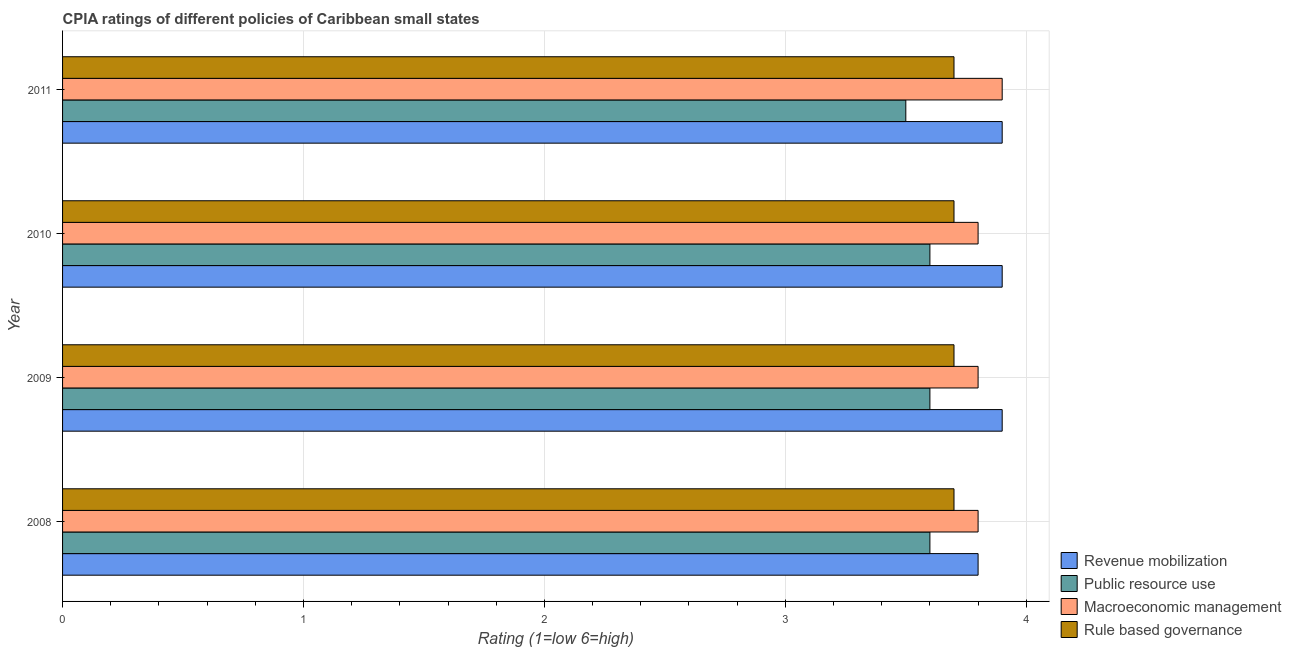How many different coloured bars are there?
Offer a terse response. 4. How many groups of bars are there?
Your answer should be compact. 4. Are the number of bars on each tick of the Y-axis equal?
Your response must be concise. Yes. How many bars are there on the 2nd tick from the bottom?
Provide a short and direct response. 4. In how many cases, is the number of bars for a given year not equal to the number of legend labels?
Give a very brief answer. 0. What is the cpia rating of macroeconomic management in 2009?
Provide a short and direct response. 3.8. In which year was the cpia rating of revenue mobilization maximum?
Provide a short and direct response. 2009. In which year was the cpia rating of public resource use minimum?
Provide a short and direct response. 2011. What is the difference between the cpia rating of macroeconomic management in 2008 and that in 2009?
Your answer should be very brief. 0. What is the difference between the cpia rating of revenue mobilization in 2008 and the cpia rating of macroeconomic management in 2011?
Your answer should be very brief. -0.1. What is the average cpia rating of revenue mobilization per year?
Make the answer very short. 3.88. In the year 2009, what is the difference between the cpia rating of rule based governance and cpia rating of public resource use?
Provide a short and direct response. 0.1. In how many years, is the cpia rating of public resource use greater than 3.2 ?
Ensure brevity in your answer.  4. Is the cpia rating of public resource use in 2010 less than that in 2011?
Give a very brief answer. No. Is the difference between the cpia rating of macroeconomic management in 2008 and 2010 greater than the difference between the cpia rating of revenue mobilization in 2008 and 2010?
Provide a succinct answer. Yes. What is the difference between the highest and the second highest cpia rating of rule based governance?
Provide a short and direct response. 0. What is the difference between the highest and the lowest cpia rating of public resource use?
Your answer should be compact. 0.1. In how many years, is the cpia rating of public resource use greater than the average cpia rating of public resource use taken over all years?
Give a very brief answer. 3. Is the sum of the cpia rating of rule based governance in 2010 and 2011 greater than the maximum cpia rating of revenue mobilization across all years?
Offer a terse response. Yes. What does the 1st bar from the top in 2011 represents?
Provide a succinct answer. Rule based governance. What does the 2nd bar from the bottom in 2010 represents?
Make the answer very short. Public resource use. What is the difference between two consecutive major ticks on the X-axis?
Keep it short and to the point. 1. Does the graph contain any zero values?
Offer a terse response. No. Does the graph contain grids?
Your answer should be very brief. Yes. Where does the legend appear in the graph?
Ensure brevity in your answer.  Bottom right. How are the legend labels stacked?
Provide a succinct answer. Vertical. What is the title of the graph?
Ensure brevity in your answer.  CPIA ratings of different policies of Caribbean small states. What is the label or title of the X-axis?
Offer a terse response. Rating (1=low 6=high). What is the label or title of the Y-axis?
Provide a succinct answer. Year. What is the Rating (1=low 6=high) in Public resource use in 2008?
Make the answer very short. 3.6. What is the Rating (1=low 6=high) in Rule based governance in 2008?
Your answer should be compact. 3.7. What is the Rating (1=low 6=high) in Public resource use in 2009?
Your response must be concise. 3.6. What is the Rating (1=low 6=high) of Rule based governance in 2009?
Ensure brevity in your answer.  3.7. What is the Rating (1=low 6=high) in Revenue mobilization in 2010?
Ensure brevity in your answer.  3.9. What is the Rating (1=low 6=high) of Public resource use in 2010?
Offer a very short reply. 3.6. What is the Rating (1=low 6=high) in Revenue mobilization in 2011?
Ensure brevity in your answer.  3.9. What is the Rating (1=low 6=high) in Macroeconomic management in 2011?
Your response must be concise. 3.9. What is the Rating (1=low 6=high) in Rule based governance in 2011?
Give a very brief answer. 3.7. Across all years, what is the maximum Rating (1=low 6=high) in Public resource use?
Provide a short and direct response. 3.6. Across all years, what is the maximum Rating (1=low 6=high) of Rule based governance?
Keep it short and to the point. 3.7. Across all years, what is the minimum Rating (1=low 6=high) of Revenue mobilization?
Offer a terse response. 3.8. What is the total Rating (1=low 6=high) in Public resource use in the graph?
Provide a succinct answer. 14.3. What is the total Rating (1=low 6=high) in Macroeconomic management in the graph?
Your response must be concise. 15.3. What is the difference between the Rating (1=low 6=high) of Public resource use in 2008 and that in 2009?
Your response must be concise. 0. What is the difference between the Rating (1=low 6=high) of Macroeconomic management in 2008 and that in 2009?
Keep it short and to the point. 0. What is the difference between the Rating (1=low 6=high) of Rule based governance in 2008 and that in 2009?
Provide a short and direct response. 0. What is the difference between the Rating (1=low 6=high) in Public resource use in 2008 and that in 2010?
Give a very brief answer. 0. What is the difference between the Rating (1=low 6=high) in Rule based governance in 2008 and that in 2010?
Provide a short and direct response. 0. What is the difference between the Rating (1=low 6=high) of Rule based governance in 2008 and that in 2011?
Make the answer very short. 0. What is the difference between the Rating (1=low 6=high) of Public resource use in 2009 and that in 2010?
Provide a short and direct response. 0. What is the difference between the Rating (1=low 6=high) of Macroeconomic management in 2009 and that in 2010?
Keep it short and to the point. 0. What is the difference between the Rating (1=low 6=high) in Revenue mobilization in 2009 and that in 2011?
Ensure brevity in your answer.  0. What is the difference between the Rating (1=low 6=high) in Rule based governance in 2009 and that in 2011?
Your response must be concise. 0. What is the difference between the Rating (1=low 6=high) of Macroeconomic management in 2010 and that in 2011?
Your answer should be compact. -0.1. What is the difference between the Rating (1=low 6=high) in Rule based governance in 2010 and that in 2011?
Keep it short and to the point. 0. What is the difference between the Rating (1=low 6=high) of Revenue mobilization in 2008 and the Rating (1=low 6=high) of Macroeconomic management in 2009?
Offer a very short reply. 0. What is the difference between the Rating (1=low 6=high) in Public resource use in 2008 and the Rating (1=low 6=high) in Rule based governance in 2009?
Your answer should be compact. -0.1. What is the difference between the Rating (1=low 6=high) of Macroeconomic management in 2008 and the Rating (1=low 6=high) of Rule based governance in 2009?
Ensure brevity in your answer.  0.1. What is the difference between the Rating (1=low 6=high) in Revenue mobilization in 2008 and the Rating (1=low 6=high) in Rule based governance in 2010?
Your answer should be compact. 0.1. What is the difference between the Rating (1=low 6=high) in Public resource use in 2008 and the Rating (1=low 6=high) in Macroeconomic management in 2010?
Provide a short and direct response. -0.2. What is the difference between the Rating (1=low 6=high) of Public resource use in 2008 and the Rating (1=low 6=high) of Rule based governance in 2010?
Your response must be concise. -0.1. What is the difference between the Rating (1=low 6=high) of Revenue mobilization in 2008 and the Rating (1=low 6=high) of Public resource use in 2011?
Provide a succinct answer. 0.3. What is the difference between the Rating (1=low 6=high) in Revenue mobilization in 2008 and the Rating (1=low 6=high) in Macroeconomic management in 2011?
Offer a terse response. -0.1. What is the difference between the Rating (1=low 6=high) of Public resource use in 2008 and the Rating (1=low 6=high) of Rule based governance in 2011?
Your response must be concise. -0.1. What is the difference between the Rating (1=low 6=high) of Macroeconomic management in 2008 and the Rating (1=low 6=high) of Rule based governance in 2011?
Offer a terse response. 0.1. What is the difference between the Rating (1=low 6=high) in Revenue mobilization in 2009 and the Rating (1=low 6=high) in Public resource use in 2010?
Give a very brief answer. 0.3. What is the difference between the Rating (1=low 6=high) in Public resource use in 2009 and the Rating (1=low 6=high) in Macroeconomic management in 2010?
Your answer should be very brief. -0.2. What is the difference between the Rating (1=low 6=high) in Macroeconomic management in 2009 and the Rating (1=low 6=high) in Rule based governance in 2010?
Make the answer very short. 0.1. What is the difference between the Rating (1=low 6=high) of Revenue mobilization in 2009 and the Rating (1=low 6=high) of Public resource use in 2011?
Give a very brief answer. 0.4. What is the difference between the Rating (1=low 6=high) of Revenue mobilization in 2009 and the Rating (1=low 6=high) of Macroeconomic management in 2011?
Ensure brevity in your answer.  0. What is the difference between the Rating (1=low 6=high) of Revenue mobilization in 2009 and the Rating (1=low 6=high) of Rule based governance in 2011?
Provide a succinct answer. 0.2. What is the difference between the Rating (1=low 6=high) of Public resource use in 2009 and the Rating (1=low 6=high) of Rule based governance in 2011?
Give a very brief answer. -0.1. What is the difference between the Rating (1=low 6=high) in Macroeconomic management in 2009 and the Rating (1=low 6=high) in Rule based governance in 2011?
Your answer should be very brief. 0.1. What is the difference between the Rating (1=low 6=high) in Revenue mobilization in 2010 and the Rating (1=low 6=high) in Macroeconomic management in 2011?
Provide a short and direct response. 0. What is the difference between the Rating (1=low 6=high) in Public resource use in 2010 and the Rating (1=low 6=high) in Macroeconomic management in 2011?
Give a very brief answer. -0.3. What is the difference between the Rating (1=low 6=high) in Public resource use in 2010 and the Rating (1=low 6=high) in Rule based governance in 2011?
Provide a short and direct response. -0.1. What is the difference between the Rating (1=low 6=high) in Macroeconomic management in 2010 and the Rating (1=low 6=high) in Rule based governance in 2011?
Your answer should be compact. 0.1. What is the average Rating (1=low 6=high) of Revenue mobilization per year?
Keep it short and to the point. 3.88. What is the average Rating (1=low 6=high) in Public resource use per year?
Make the answer very short. 3.58. What is the average Rating (1=low 6=high) in Macroeconomic management per year?
Your answer should be very brief. 3.83. In the year 2008, what is the difference between the Rating (1=low 6=high) in Revenue mobilization and Rating (1=low 6=high) in Public resource use?
Ensure brevity in your answer.  0.2. In the year 2008, what is the difference between the Rating (1=low 6=high) of Revenue mobilization and Rating (1=low 6=high) of Macroeconomic management?
Offer a terse response. 0. In the year 2008, what is the difference between the Rating (1=low 6=high) of Public resource use and Rating (1=low 6=high) of Rule based governance?
Give a very brief answer. -0.1. In the year 2008, what is the difference between the Rating (1=low 6=high) in Macroeconomic management and Rating (1=low 6=high) in Rule based governance?
Provide a succinct answer. 0.1. In the year 2009, what is the difference between the Rating (1=low 6=high) in Revenue mobilization and Rating (1=low 6=high) in Public resource use?
Your answer should be compact. 0.3. In the year 2009, what is the difference between the Rating (1=low 6=high) of Revenue mobilization and Rating (1=low 6=high) of Rule based governance?
Offer a very short reply. 0.2. In the year 2009, what is the difference between the Rating (1=low 6=high) of Public resource use and Rating (1=low 6=high) of Macroeconomic management?
Your response must be concise. -0.2. In the year 2009, what is the difference between the Rating (1=low 6=high) in Public resource use and Rating (1=low 6=high) in Rule based governance?
Your answer should be compact. -0.1. In the year 2009, what is the difference between the Rating (1=low 6=high) in Macroeconomic management and Rating (1=low 6=high) in Rule based governance?
Make the answer very short. 0.1. In the year 2010, what is the difference between the Rating (1=low 6=high) in Revenue mobilization and Rating (1=low 6=high) in Public resource use?
Your response must be concise. 0.3. In the year 2010, what is the difference between the Rating (1=low 6=high) of Revenue mobilization and Rating (1=low 6=high) of Macroeconomic management?
Provide a succinct answer. 0.1. In the year 2010, what is the difference between the Rating (1=low 6=high) in Macroeconomic management and Rating (1=low 6=high) in Rule based governance?
Keep it short and to the point. 0.1. In the year 2011, what is the difference between the Rating (1=low 6=high) in Revenue mobilization and Rating (1=low 6=high) in Public resource use?
Your answer should be very brief. 0.4. In the year 2011, what is the difference between the Rating (1=low 6=high) in Revenue mobilization and Rating (1=low 6=high) in Rule based governance?
Ensure brevity in your answer.  0.2. In the year 2011, what is the difference between the Rating (1=low 6=high) of Public resource use and Rating (1=low 6=high) of Macroeconomic management?
Your answer should be compact. -0.4. In the year 2011, what is the difference between the Rating (1=low 6=high) in Macroeconomic management and Rating (1=low 6=high) in Rule based governance?
Provide a short and direct response. 0.2. What is the ratio of the Rating (1=low 6=high) in Revenue mobilization in 2008 to that in 2009?
Give a very brief answer. 0.97. What is the ratio of the Rating (1=low 6=high) in Revenue mobilization in 2008 to that in 2010?
Make the answer very short. 0.97. What is the ratio of the Rating (1=low 6=high) of Revenue mobilization in 2008 to that in 2011?
Your answer should be compact. 0.97. What is the ratio of the Rating (1=low 6=high) in Public resource use in 2008 to that in 2011?
Ensure brevity in your answer.  1.03. What is the ratio of the Rating (1=low 6=high) of Macroeconomic management in 2008 to that in 2011?
Provide a short and direct response. 0.97. What is the ratio of the Rating (1=low 6=high) in Rule based governance in 2008 to that in 2011?
Make the answer very short. 1. What is the ratio of the Rating (1=low 6=high) of Revenue mobilization in 2009 to that in 2010?
Give a very brief answer. 1. What is the ratio of the Rating (1=low 6=high) in Public resource use in 2009 to that in 2010?
Keep it short and to the point. 1. What is the ratio of the Rating (1=low 6=high) of Macroeconomic management in 2009 to that in 2010?
Your answer should be compact. 1. What is the ratio of the Rating (1=low 6=high) of Rule based governance in 2009 to that in 2010?
Provide a short and direct response. 1. What is the ratio of the Rating (1=low 6=high) in Public resource use in 2009 to that in 2011?
Keep it short and to the point. 1.03. What is the ratio of the Rating (1=low 6=high) of Macroeconomic management in 2009 to that in 2011?
Keep it short and to the point. 0.97. What is the ratio of the Rating (1=low 6=high) of Revenue mobilization in 2010 to that in 2011?
Give a very brief answer. 1. What is the ratio of the Rating (1=low 6=high) of Public resource use in 2010 to that in 2011?
Give a very brief answer. 1.03. What is the ratio of the Rating (1=low 6=high) in Macroeconomic management in 2010 to that in 2011?
Provide a short and direct response. 0.97. What is the ratio of the Rating (1=low 6=high) in Rule based governance in 2010 to that in 2011?
Make the answer very short. 1. What is the difference between the highest and the second highest Rating (1=low 6=high) in Macroeconomic management?
Provide a succinct answer. 0.1. What is the difference between the highest and the second highest Rating (1=low 6=high) of Rule based governance?
Keep it short and to the point. 0. What is the difference between the highest and the lowest Rating (1=low 6=high) in Revenue mobilization?
Provide a short and direct response. 0.1. What is the difference between the highest and the lowest Rating (1=low 6=high) in Public resource use?
Your response must be concise. 0.1. What is the difference between the highest and the lowest Rating (1=low 6=high) of Macroeconomic management?
Your answer should be very brief. 0.1. What is the difference between the highest and the lowest Rating (1=low 6=high) of Rule based governance?
Give a very brief answer. 0. 